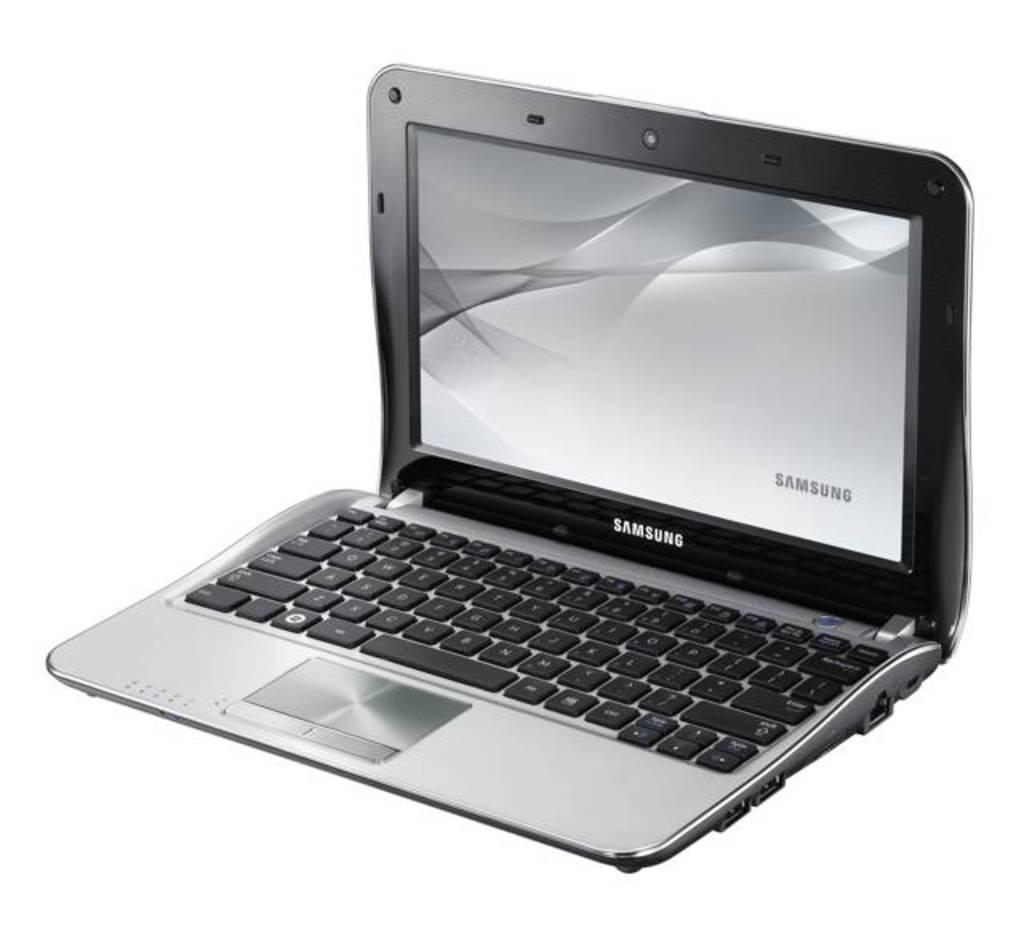<image>
Provide a brief description of the given image. A gray and silver Samsung laptop opened with the screen displaying Samsung. 